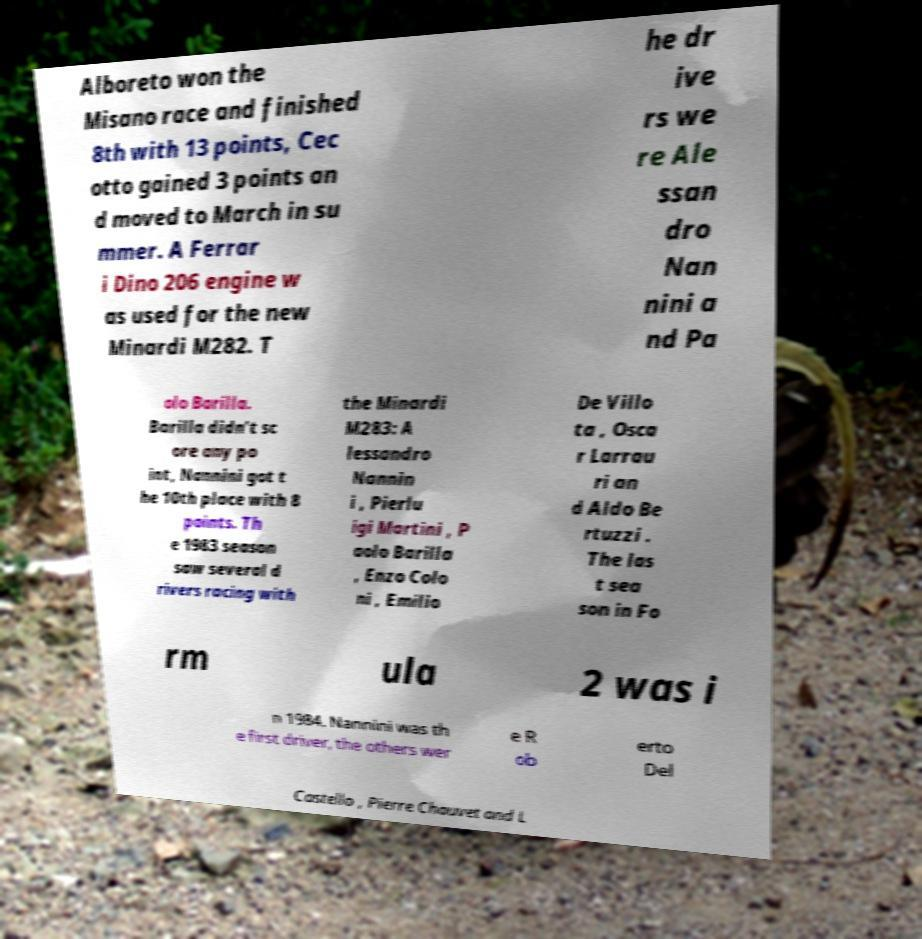I need the written content from this picture converted into text. Can you do that? Alboreto won the Misano race and finished 8th with 13 points, Cec otto gained 3 points an d moved to March in su mmer. A Ferrar i Dino 206 engine w as used for the new Minardi M282. T he dr ive rs we re Ale ssan dro Nan nini a nd Pa olo Barilla. Barilla didn’t sc ore any po int, Nannini got t he 10th place with 8 points. Th e 1983 season saw several d rivers racing with the Minardi M283: A lessandro Nannin i , Pierlu igi Martini , P aolo Barilla , Enzo Colo ni , Emilio De Villo ta , Osca r Larrau ri an d Aldo Be rtuzzi . The las t sea son in Fo rm ula 2 was i n 1984. Nannini was th e first driver, the others wer e R ob erto Del Castello , Pierre Chauvet and L 